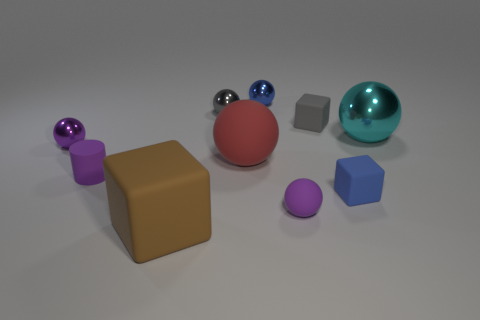The cylinder that is the same color as the small matte sphere is what size? small 